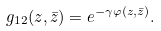<formula> <loc_0><loc_0><loc_500><loc_500>g _ { 1 2 } ( z , \bar { z } ) = e ^ { - \gamma \varphi ( z , \bar { z } ) } .</formula> 